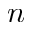Convert formula to latex. <formula><loc_0><loc_0><loc_500><loc_500>n</formula> 